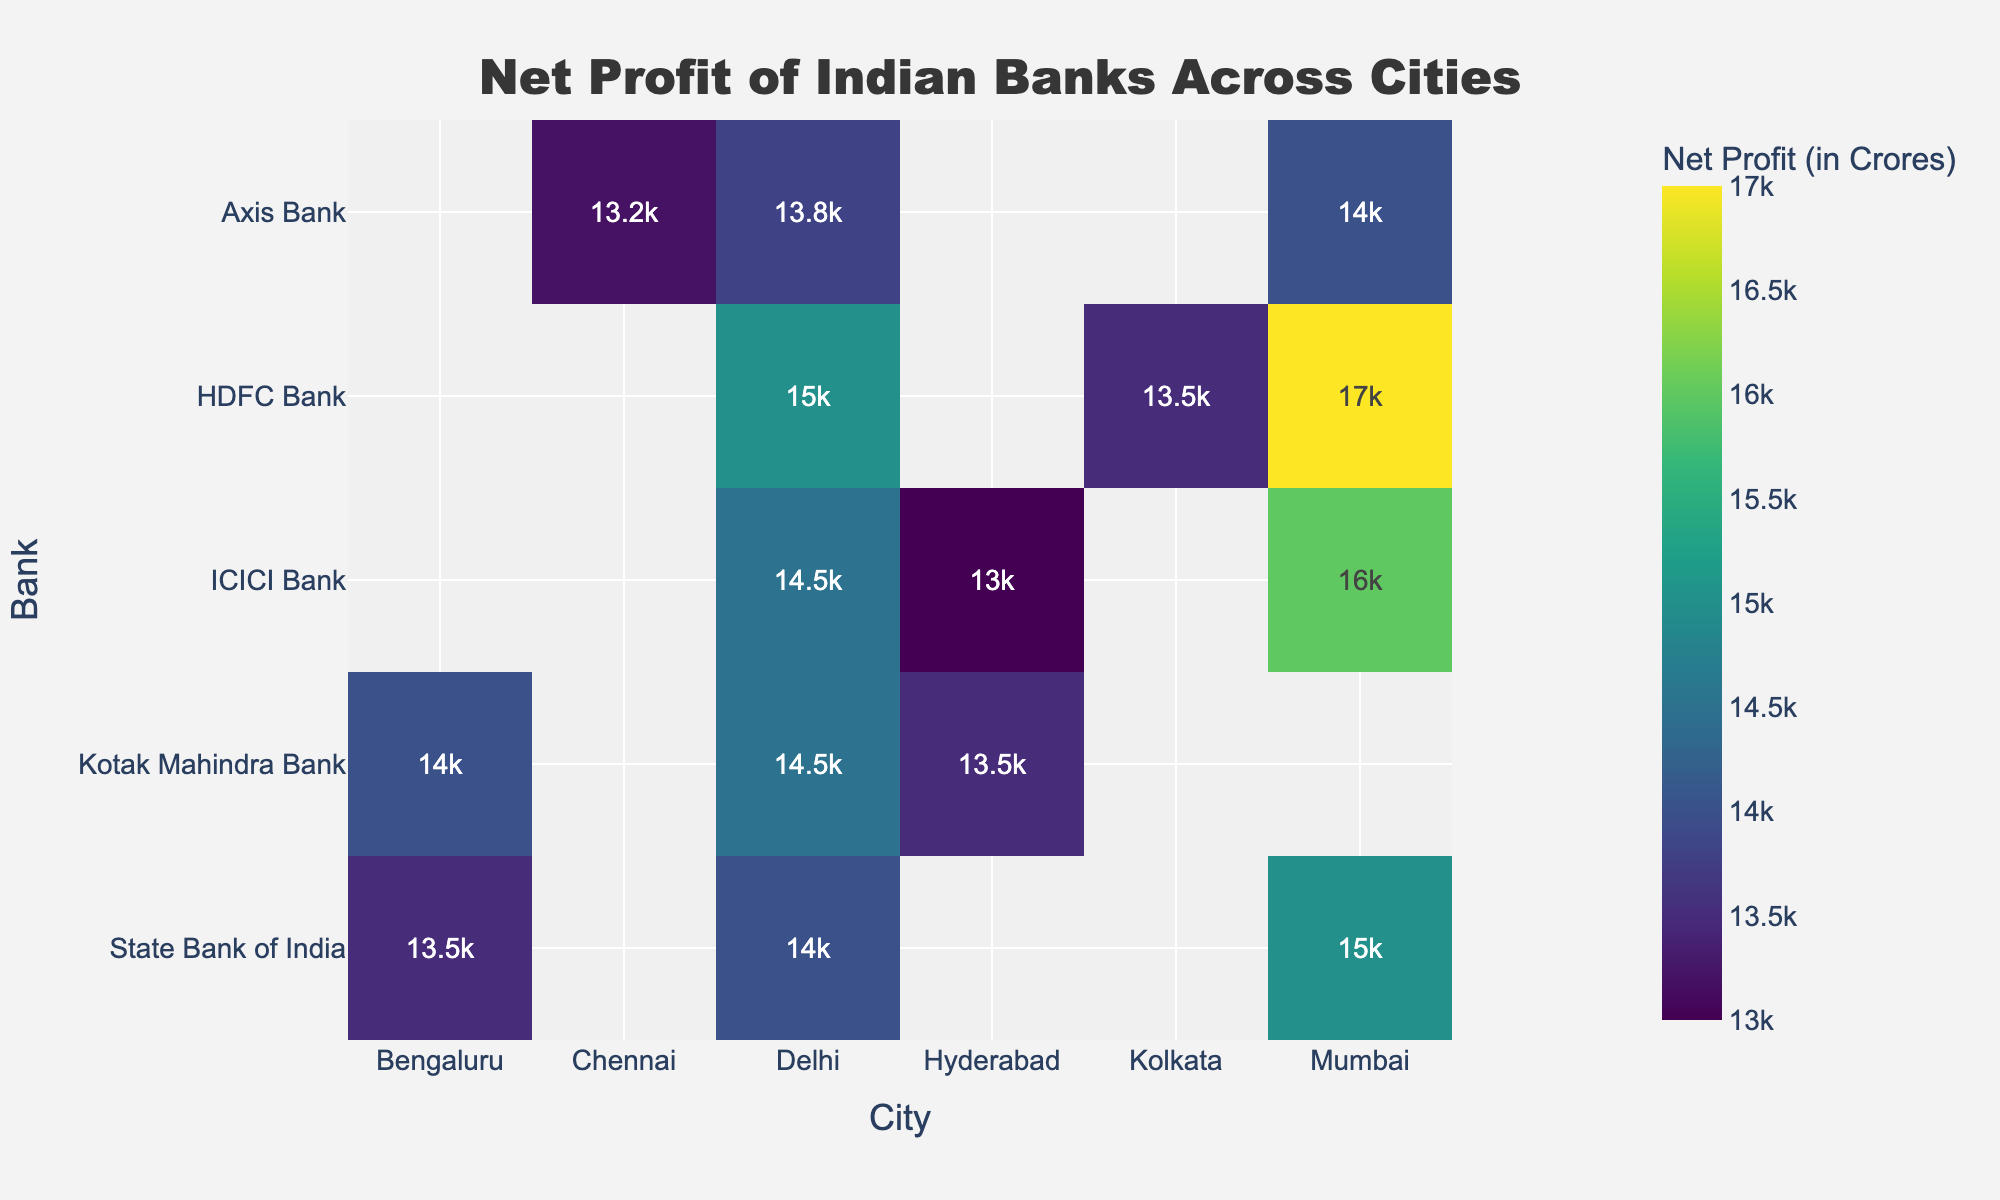Which city shows the highest net profit for HDFC Bank? Look at the color intensity representing net profit values for HDFC Bank across different cities. The deepest color indicates the highest value.
Answer: Mumbai What is the net profit difference between ICICI Bank in Mumbai and Delhi? Identify the net profit values for ICICI Bank in Mumbai and Delhi, subtract the smaller value from the larger one. Mumbai is 16000 and Delhi is 14500. 16000 - 14500 = 1500.
Answer: 1500 Which bank has the lowest net profit in Chennai? Find the color intensity representing net profit values for banks across Chennai and identify the bank with the lightest shade.
Answer: Axis Bank Compare the net profit of Kotak Mahindra Bank in Bengaluru and Hyderabad. Which is higher? Look at the net profit values for Kotak Mahindra Bank in both Bengaluru and Hyderabad. Identify which is higher by comparing the color intensities. Bengaluru is 14000 and Hyderabad is 13500. 14000 > 13500.
Answer: Bengaluru What is the average net profit of all banks in Mumbai? Sum the net profit values for all banks in Mumbai and divide by the number of banks. (15000 + 16000 + 17000 + 14000) / 4 = 62000 / 4.
Answer: 15500 Which city does not have data for Kotak Mahindra Bank on the heatmap? Look at the cities listed on the x-axis and check which column has no entry for Kotak Mahindra Bank.
Answer: Mumbai Among the data points shown, which bank holds the highest net profit in a single city across all cities? Identify the cell with the deepest color in the heatmap, indicating the highest net profit value.
Answer: HDFC Bank in Mumbai How many cities are represented in the heatmap? Count the distinct city labels along the x-axis.
Answer: 7 Which two cities show the net profits of all banks below 15000? Identify the cities where no bank achieves a net profit value of 15000 or higher, indicated by the absence of the darkest colors in that range.
Answer: Chennai and Hyderabad 